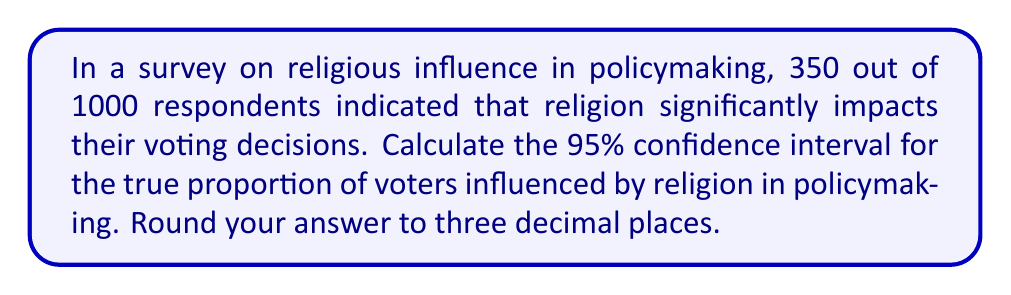Provide a solution to this math problem. To calculate the confidence interval, we'll use the formula for a proportion:

$$CI = \hat{p} \pm z\sqrt{\frac{\hat{p}(1-\hat{p})}{n}}$$

Where:
$\hat{p}$ = sample proportion
$z$ = z-score for desired confidence level (1.96 for 95% CI)
$n$ = sample size

Step 1: Calculate the sample proportion
$\hat{p} = \frac{350}{1000} = 0.35$

Step 2: Calculate the standard error
$$SE = \sqrt{\frac{\hat{p}(1-\hat{p})}{n}} = \sqrt{\frac{0.35(1-0.35)}{1000}} = 0.0151$$

Step 3: Calculate the margin of error
$$ME = z \times SE = 1.96 \times 0.0151 = 0.0296$$

Step 4: Calculate the confidence interval
Lower bound: $0.35 - 0.0296 = 0.3204$
Upper bound: $0.35 + 0.0296 = 0.3796$

Rounding to three decimal places:
Lower bound: 0.320
Upper bound: 0.380
Answer: (0.320, 0.380) 